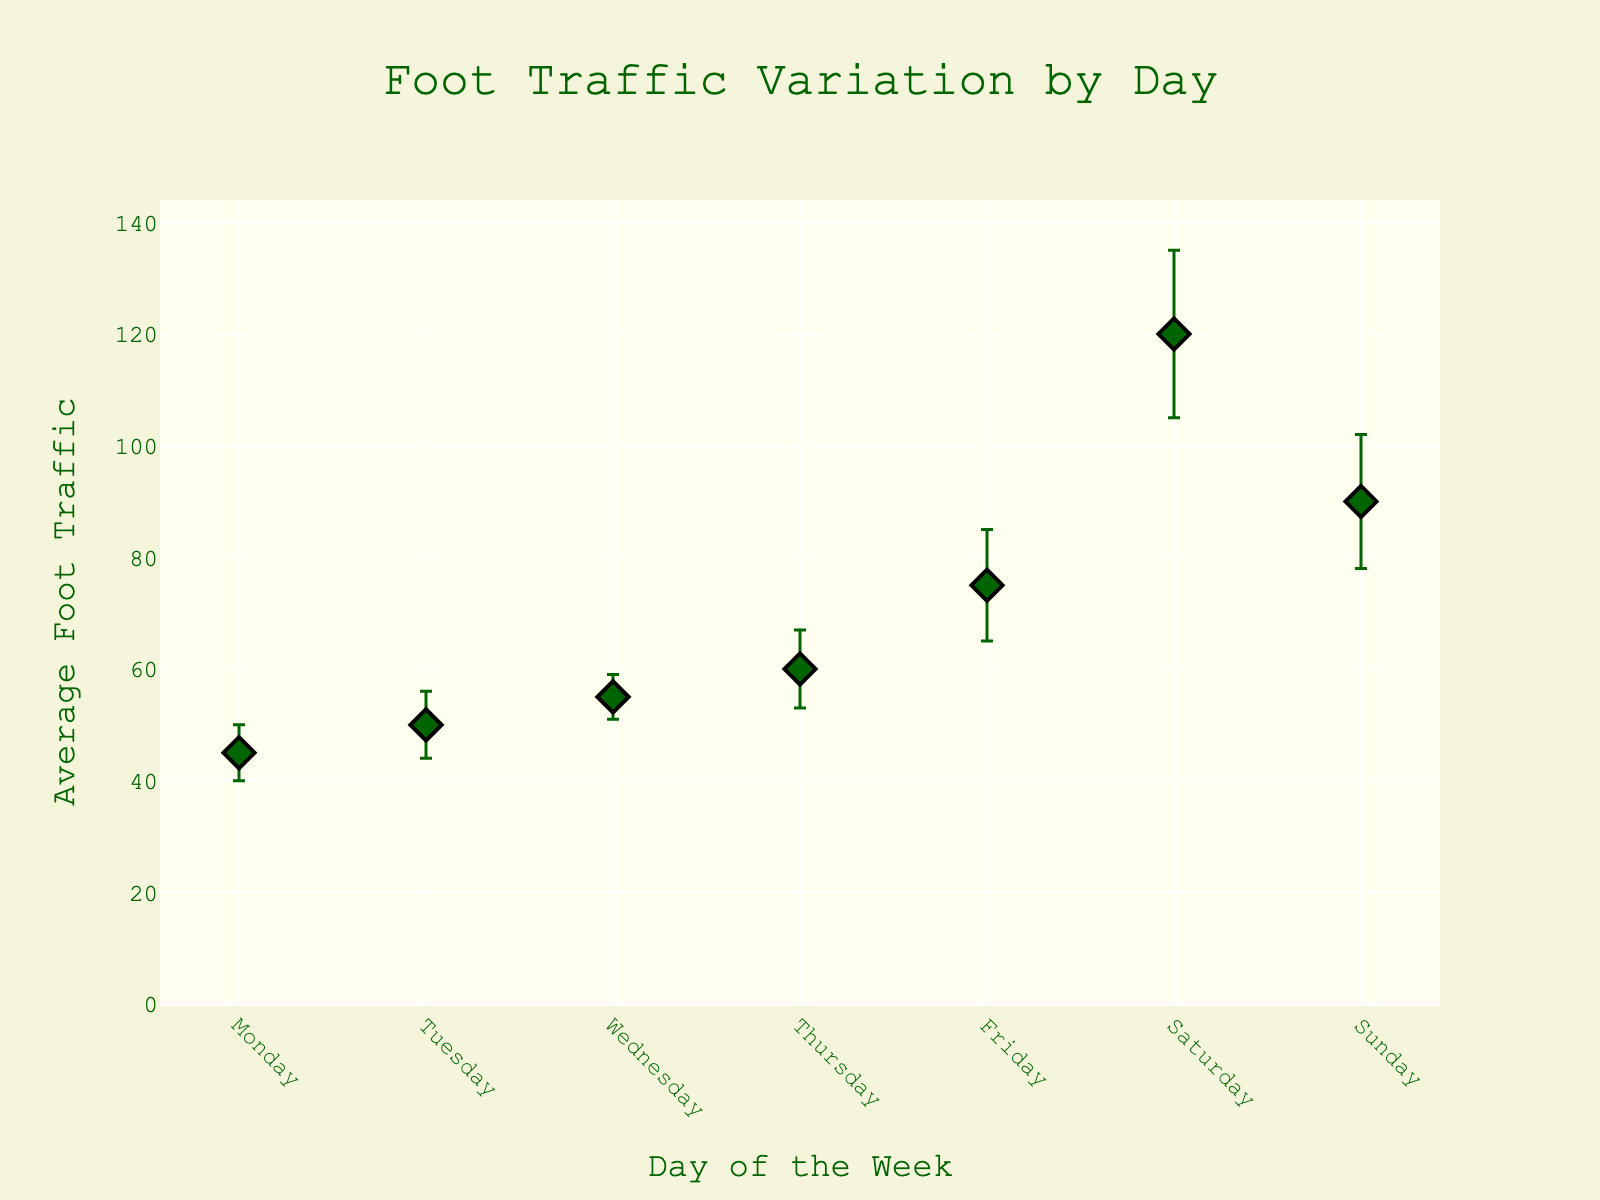How many days of the week are represented in the plot? The plot has markers for each day from Monday to Sunday. Count the total days listed on the x-axis.
Answer: 7 Which day has the highest average foot traffic? Look at the data points on the y-axis and identify which day has the highest position.
Answer: Saturday How does the average foot traffic on Thursday compare to Monday? Check the y-axis values for both Thursday and Monday. Subtract the average foot traffic of Monday from Thursday.
Answer: 15 (Thursday is 15 higher than Monday) On which day do the error bars indicate the highest variability in foot traffic? Examine the length of the error bars for each day. The day with the longest error bars indicates the highest variability.
Answer: Saturday What is the difference in average foot traffic between the day with the highest value and the day with the lowest value? Find the highest average foot traffic (Saturday) and the lowest (Monday). Subtract the lowest value from the highest.
Answer: 75 What is the average foot traffic on weekends? Sum the foot traffic for Saturday and Sunday, then divide by 2. (120 + 90) / 2 = 105.
Answer: 105 What is the total average foot traffic from Monday to Wednesday? Add the average foot traffic values for Monday, Tuesday, and Wednesday. 45 + 50 + 55 = 150.
Answer: 150 How does the foot traffic on Friday compare to Sunday? Check the values for Friday and Sunday. Subtract Friday's average foot traffic from Sunday's.
Answer: 15 (Friday is 15 higher than Sunday) Which days have a higher average foot traffic than Wednesday? Compare the days listed and see which have higher y-axis values than Wednesday. Thursdays, Fridays, Saturdays, and Sundays are higher.
Answer: Thursday, Friday, Saturday, Sunday What is the range of average foot traffic shown in the plot? Identify the lowest and highest values on the y-axis. Subtract the lowest value from the highest. 120 (Saturday) - 45 (Monday) = 75.
Answer: 75 